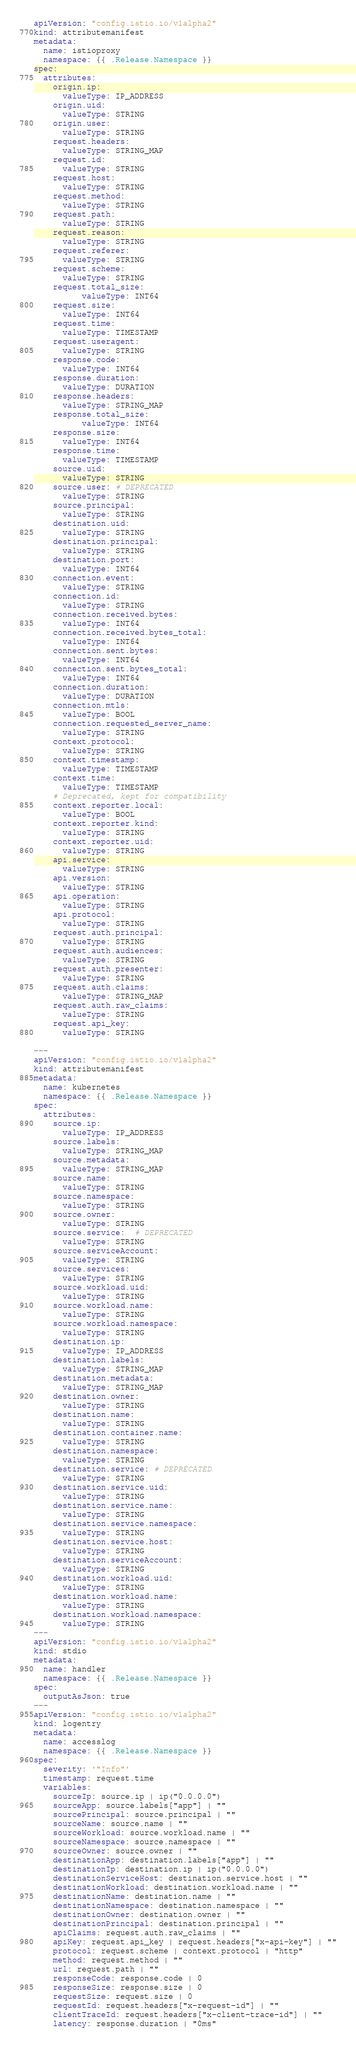<code> <loc_0><loc_0><loc_500><loc_500><_YAML_>apiVersion: "config.istio.io/v1alpha2"
kind: attributemanifest
metadata:
  name: istioproxy
  namespace: {{ .Release.Namespace }}
spec:
  attributes:
    origin.ip:
      valueType: IP_ADDRESS
    origin.uid:
      valueType: STRING
    origin.user:
      valueType: STRING
    request.headers:
      valueType: STRING_MAP
    request.id:
      valueType: STRING
    request.host:
      valueType: STRING
    request.method:
      valueType: STRING
    request.path:
      valueType: STRING
    request.reason:
      valueType: STRING
    request.referer:
      valueType: STRING
    request.scheme:
      valueType: STRING
    request.total_size:
          valueType: INT64
    request.size:
      valueType: INT64
    request.time:
      valueType: TIMESTAMP
    request.useragent:
      valueType: STRING
    response.code:
      valueType: INT64
    response.duration:
      valueType: DURATION
    response.headers:
      valueType: STRING_MAP
    response.total_size:
          valueType: INT64
    response.size:
      valueType: INT64
    response.time:
      valueType: TIMESTAMP
    source.uid:
      valueType: STRING
    source.user: # DEPRECATED
      valueType: STRING
    source.principal:
      valueType: STRING
    destination.uid:
      valueType: STRING
    destination.principal:
      valueType: STRING
    destination.port:
      valueType: INT64
    connection.event:
      valueType: STRING
    connection.id:
      valueType: STRING
    connection.received.bytes:
      valueType: INT64
    connection.received.bytes_total:
      valueType: INT64
    connection.sent.bytes:
      valueType: INT64
    connection.sent.bytes_total:
      valueType: INT64
    connection.duration:
      valueType: DURATION
    connection.mtls:
      valueType: BOOL
    connection.requested_server_name:
      valueType: STRING
    context.protocol:
      valueType: STRING
    context.timestamp:
      valueType: TIMESTAMP
    context.time:
      valueType: TIMESTAMP
    # Deprecated, kept for compatibility
    context.reporter.local:
      valueType: BOOL
    context.reporter.kind:
      valueType: STRING
    context.reporter.uid:
      valueType: STRING
    api.service:
      valueType: STRING
    api.version:
      valueType: STRING
    api.operation:
      valueType: STRING
    api.protocol:
      valueType: STRING
    request.auth.principal:
      valueType: STRING
    request.auth.audiences:
      valueType: STRING
    request.auth.presenter:
      valueType: STRING
    request.auth.claims:
      valueType: STRING_MAP
    request.auth.raw_claims:
      valueType: STRING
    request.api_key:
      valueType: STRING

---
apiVersion: "config.istio.io/v1alpha2"
kind: attributemanifest
metadata:
  name: kubernetes
  namespace: {{ .Release.Namespace }}
spec:
  attributes:
    source.ip:
      valueType: IP_ADDRESS
    source.labels:
      valueType: STRING_MAP
    source.metadata:
      valueType: STRING_MAP
    source.name:
      valueType: STRING
    source.namespace:
      valueType: STRING
    source.owner:
      valueType: STRING
    source.service:  # DEPRECATED
      valueType: STRING
    source.serviceAccount:
      valueType: STRING
    source.services:
      valueType: STRING
    source.workload.uid:
      valueType: STRING
    source.workload.name:
      valueType: STRING
    source.workload.namespace:
      valueType: STRING
    destination.ip:
      valueType: IP_ADDRESS
    destination.labels:
      valueType: STRING_MAP
    destination.metadata:
      valueType: STRING_MAP
    destination.owner:
      valueType: STRING
    destination.name:
      valueType: STRING
    destination.container.name:
      valueType: STRING
    destination.namespace:
      valueType: STRING
    destination.service: # DEPRECATED
      valueType: STRING
    destination.service.uid:
      valueType: STRING
    destination.service.name:
      valueType: STRING
    destination.service.namespace:
      valueType: STRING
    destination.service.host:
      valueType: STRING
    destination.serviceAccount:
      valueType: STRING
    destination.workload.uid:
      valueType: STRING
    destination.workload.name:
      valueType: STRING
    destination.workload.namespace:
      valueType: STRING
---
apiVersion: "config.istio.io/v1alpha2"
kind: stdio
metadata:
  name: handler
  namespace: {{ .Release.Namespace }}
spec:
  outputAsJson: true
---
apiVersion: "config.istio.io/v1alpha2"
kind: logentry
metadata:
  name: accesslog
  namespace: {{ .Release.Namespace }}
spec:
  severity: '"Info"'
  timestamp: request.time
  variables:
    sourceIp: source.ip | ip("0.0.0.0")
    sourceApp: source.labels["app"] | ""
    sourcePrincipal: source.principal | ""
    sourceName: source.name | ""
    sourceWorkload: source.workload.name | ""
    sourceNamespace: source.namespace | ""
    sourceOwner: source.owner | ""
    destinationApp: destination.labels["app"] | ""
    destinationIp: destination.ip | ip("0.0.0.0")
    destinationServiceHost: destination.service.host | ""
    destinationWorkload: destination.workload.name | ""
    destinationName: destination.name | ""
    destinationNamespace: destination.namespace | ""
    destinationOwner: destination.owner | ""
    destinationPrincipal: destination.principal | ""
    apiClaims: request.auth.raw_claims | ""
    apiKey: request.api_key | request.headers["x-api-key"] | ""
    protocol: request.scheme | context.protocol | "http"
    method: request.method | ""
    url: request.path | ""
    responseCode: response.code | 0
    responseSize: response.size | 0
    requestSize: request.size | 0
    requestId: request.headers["x-request-id"] | ""
    clientTraceId: request.headers["x-client-trace-id"] | ""
    latency: response.duration | "0ms"</code> 